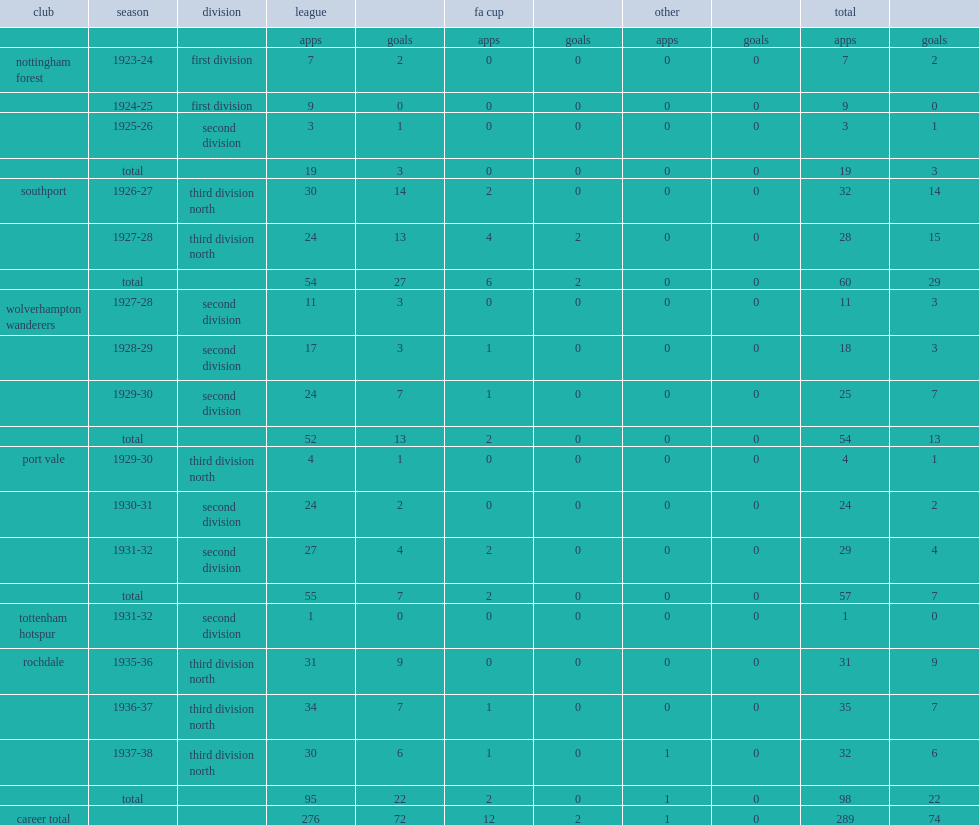How many league appearances did harry marshall make in the football league, playing for nottingham forest, southport, wolverhampton wanderers, port vale, tottenham hotspur, and rochdale? 276.0. 